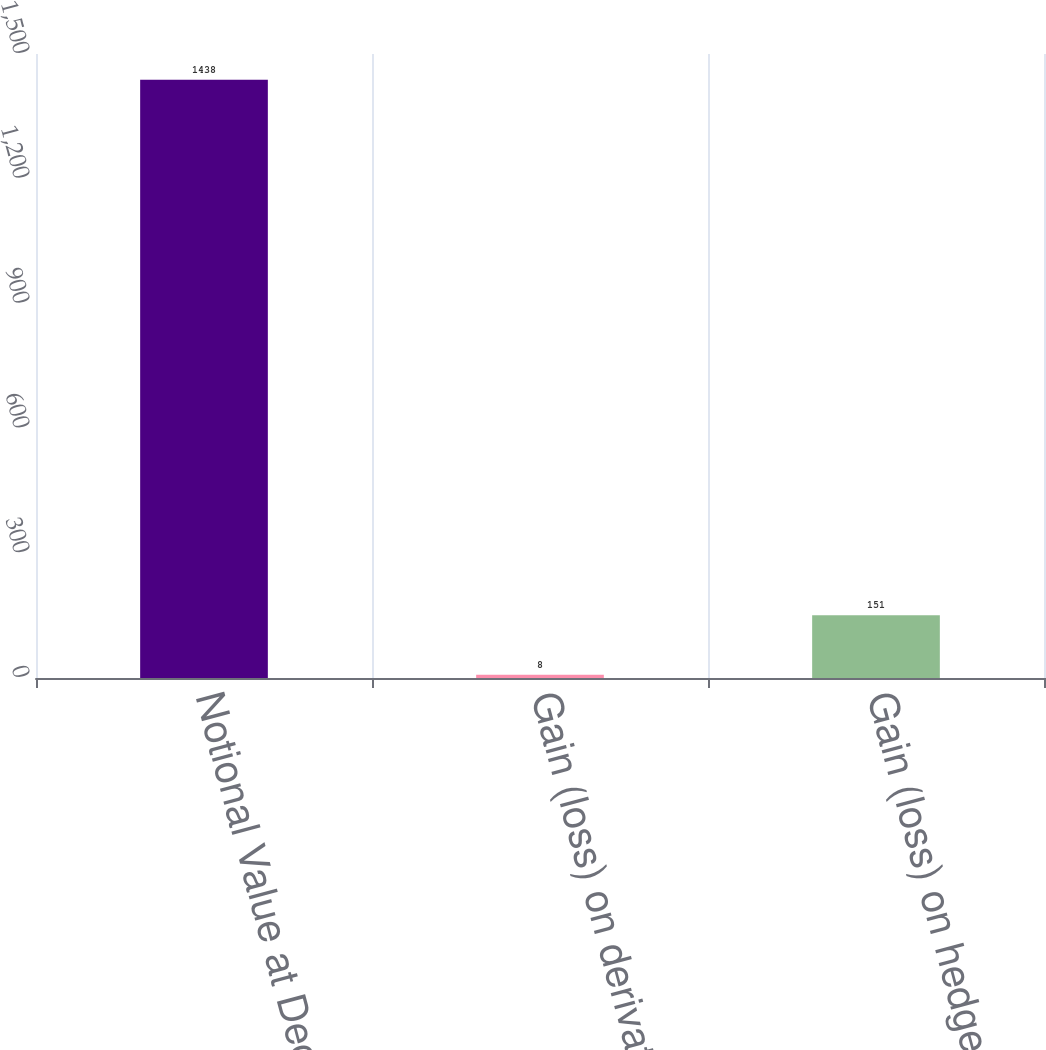Convert chart to OTSL. <chart><loc_0><loc_0><loc_500><loc_500><bar_chart><fcel>Notional Value at December 31<fcel>Gain (loss) on derivatives<fcel>Gain (loss) on hedged items<nl><fcel>1438<fcel>8<fcel>151<nl></chart> 